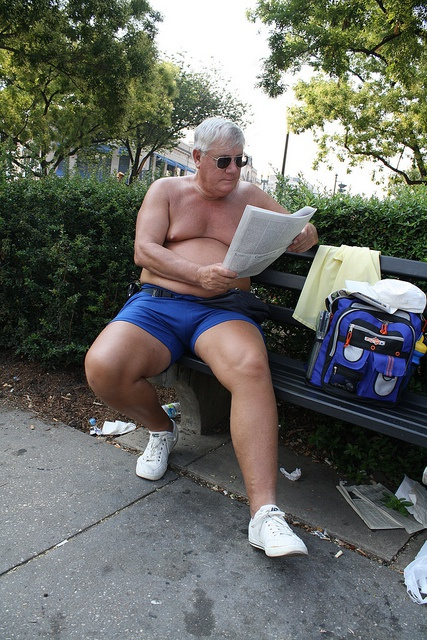Describe the objects in this image and their specific colors. I can see people in black, gray, darkgray, and brown tones, bench in black, gray, and darkblue tones, and backpack in black, navy, darkblue, and blue tones in this image. 